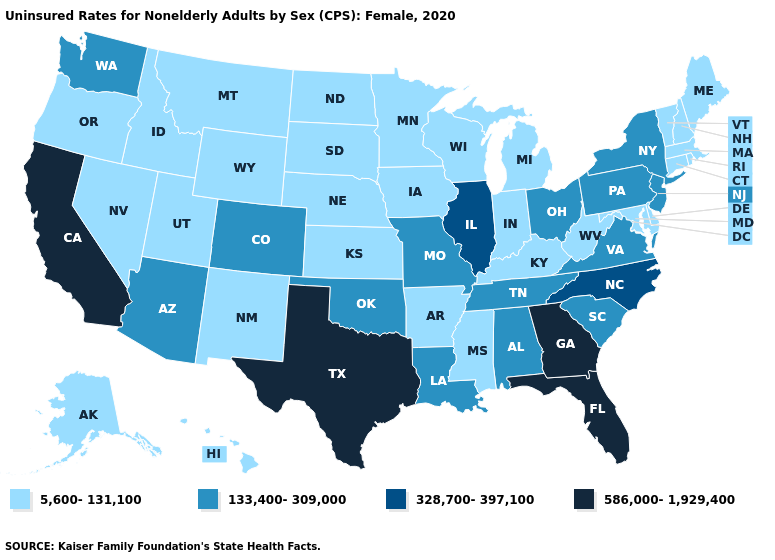Which states have the highest value in the USA?
Be succinct. California, Florida, Georgia, Texas. What is the value of Alaska?
Give a very brief answer. 5,600-131,100. Name the states that have a value in the range 586,000-1,929,400?
Concise answer only. California, Florida, Georgia, Texas. Among the states that border Missouri , does Illinois have the highest value?
Write a very short answer. Yes. Which states have the lowest value in the South?
Concise answer only. Arkansas, Delaware, Kentucky, Maryland, Mississippi, West Virginia. Which states hav the highest value in the MidWest?
Be succinct. Illinois. Name the states that have a value in the range 328,700-397,100?
Answer briefly. Illinois, North Carolina. Does Delaware have a lower value than Minnesota?
Write a very short answer. No. What is the highest value in the South ?
Answer briefly. 586,000-1,929,400. What is the value of Pennsylvania?
Concise answer only. 133,400-309,000. Name the states that have a value in the range 133,400-309,000?
Answer briefly. Alabama, Arizona, Colorado, Louisiana, Missouri, New Jersey, New York, Ohio, Oklahoma, Pennsylvania, South Carolina, Tennessee, Virginia, Washington. Name the states that have a value in the range 133,400-309,000?
Be succinct. Alabama, Arizona, Colorado, Louisiana, Missouri, New Jersey, New York, Ohio, Oklahoma, Pennsylvania, South Carolina, Tennessee, Virginia, Washington. Does New Jersey have the same value as Tennessee?
Give a very brief answer. Yes. Which states hav the highest value in the South?
Write a very short answer. Florida, Georgia, Texas. What is the value of Delaware?
Keep it brief. 5,600-131,100. 